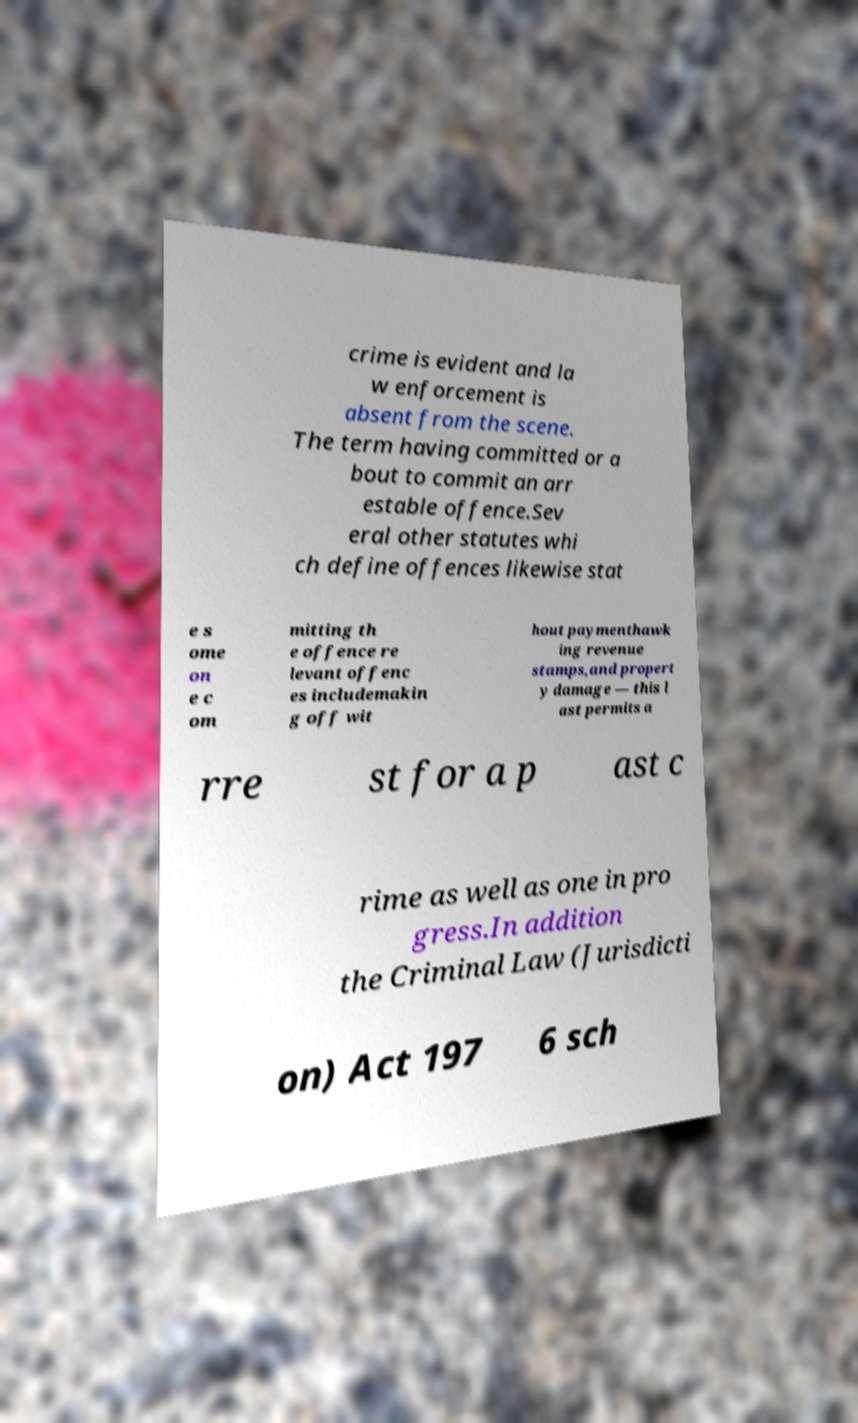Can you accurately transcribe the text from the provided image for me? crime is evident and la w enforcement is absent from the scene. The term having committed or a bout to commit an arr estable offence.Sev eral other statutes whi ch define offences likewise stat e s ome on e c om mitting th e offence re levant offenc es includemakin g off wit hout paymenthawk ing revenue stamps,and propert y damage — this l ast permits a rre st for a p ast c rime as well as one in pro gress.In addition the Criminal Law (Jurisdicti on) Act 197 6 sch 